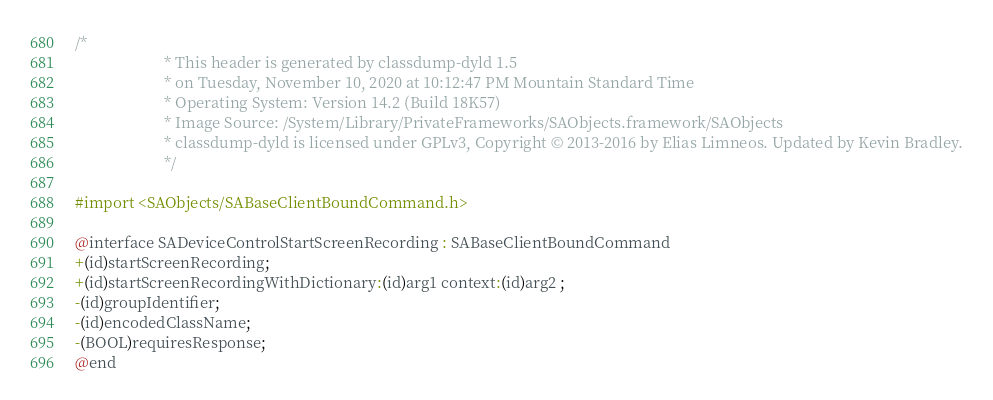Convert code to text. <code><loc_0><loc_0><loc_500><loc_500><_C_>/*
                       * This header is generated by classdump-dyld 1.5
                       * on Tuesday, November 10, 2020 at 10:12:47 PM Mountain Standard Time
                       * Operating System: Version 14.2 (Build 18K57)
                       * Image Source: /System/Library/PrivateFrameworks/SAObjects.framework/SAObjects
                       * classdump-dyld is licensed under GPLv3, Copyright © 2013-2016 by Elias Limneos. Updated by Kevin Bradley.
                       */

#import <SAObjects/SABaseClientBoundCommand.h>

@interface SADeviceControlStartScreenRecording : SABaseClientBoundCommand
+(id)startScreenRecording;
+(id)startScreenRecordingWithDictionary:(id)arg1 context:(id)arg2 ;
-(id)groupIdentifier;
-(id)encodedClassName;
-(BOOL)requiresResponse;
@end

</code> 